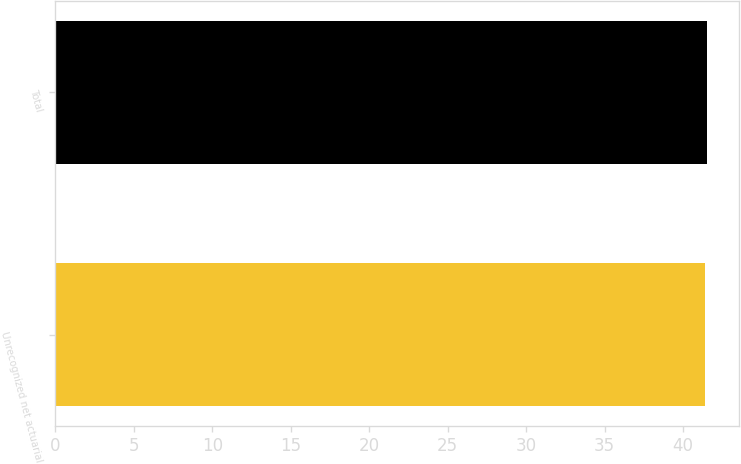Convert chart. <chart><loc_0><loc_0><loc_500><loc_500><bar_chart><fcel>Unrecognized net actuarial<fcel>Total<nl><fcel>41.4<fcel>41.5<nl></chart> 